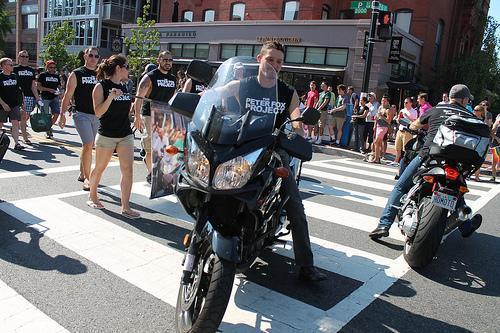How many flying motorcycles are in the picture?
Give a very brief answer. 0. 